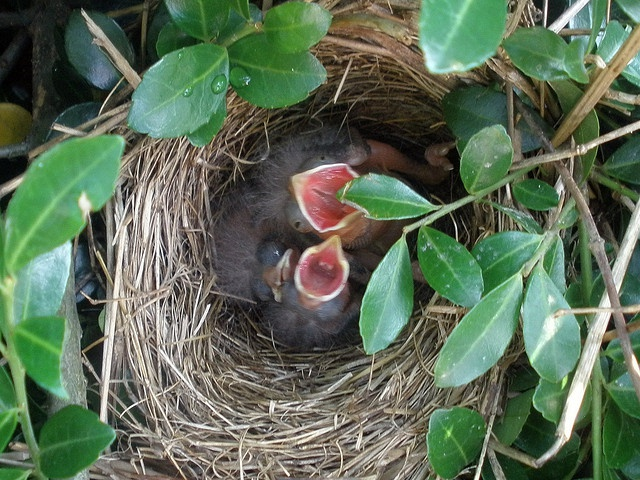Describe the objects in this image and their specific colors. I can see bird in black, gray, brown, and maroon tones, bird in black, gray, and darkgray tones, and bird in black, gray, brown, and darkgray tones in this image. 